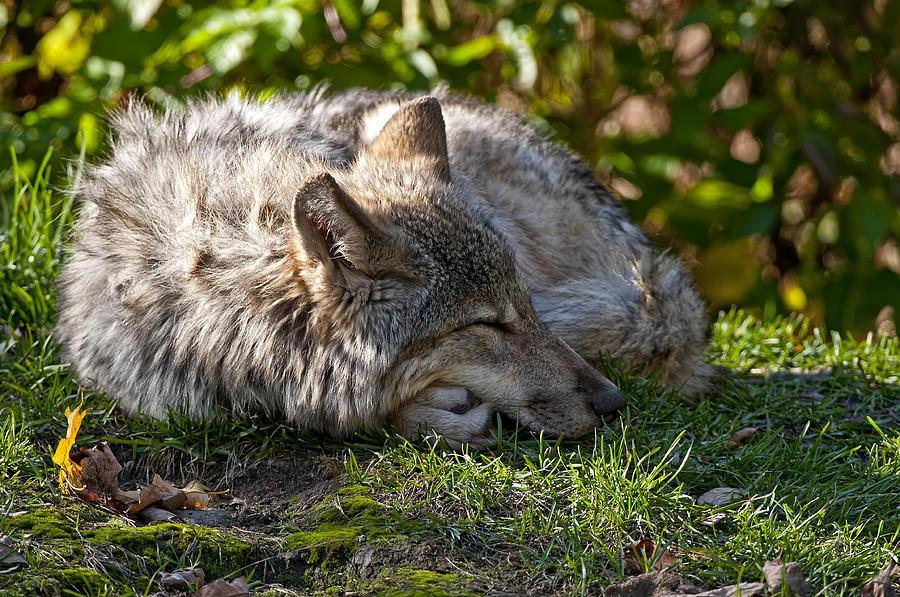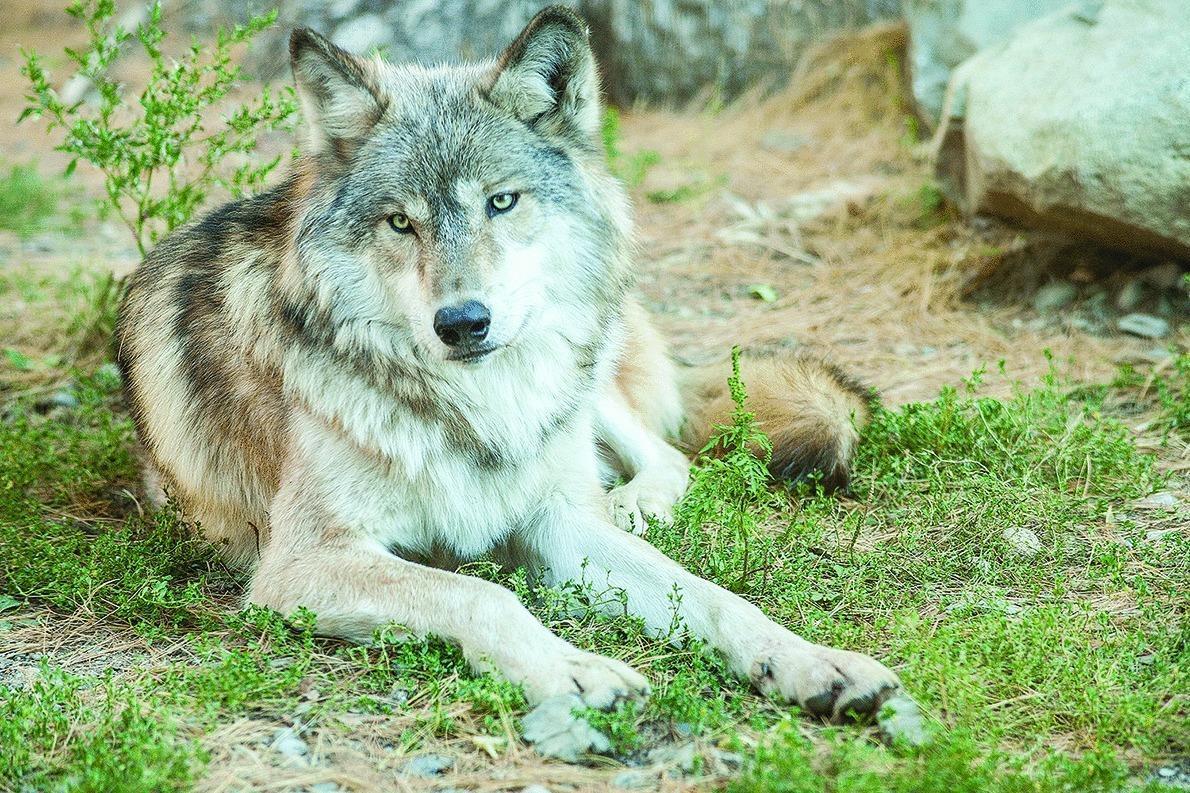The first image is the image on the left, the second image is the image on the right. Considering the images on both sides, is "One animal is lying their head across the body of another animal." valid? Answer yes or no. No. The first image is the image on the left, the second image is the image on the right. For the images shown, is this caption "In the left image, two animals are laying down together." true? Answer yes or no. No. 